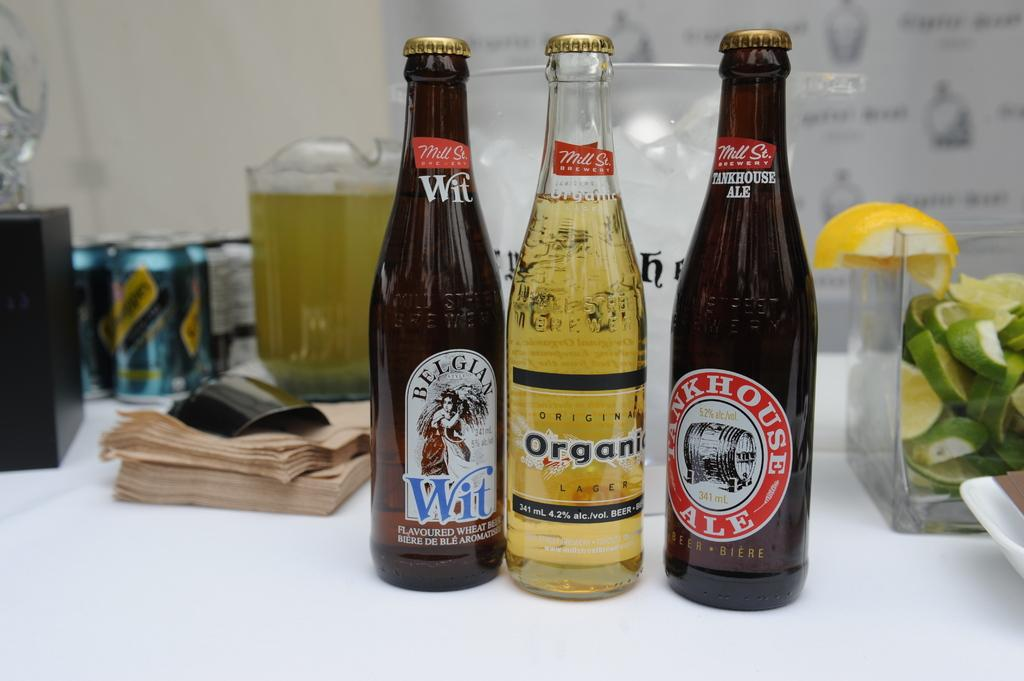<image>
Describe the image concisely. A bottle of Wit is next to a bottle of Organic beer. 